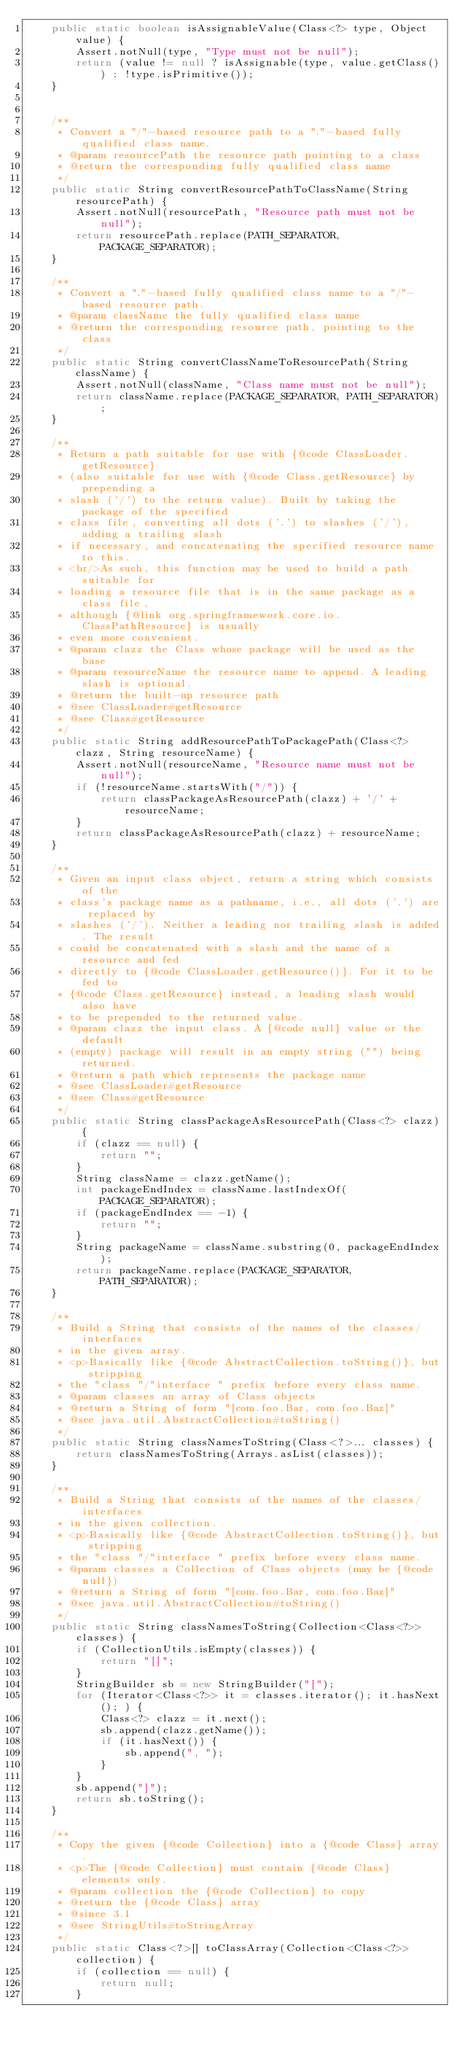Convert code to text. <code><loc_0><loc_0><loc_500><loc_500><_Java_>    public static boolean isAssignableValue(Class<?> type, Object value) {
        Assert.notNull(type, "Type must not be null");
        return (value != null ? isAssignable(type, value.getClass()) : !type.isPrimitive());
    }


    /**
     * Convert a "/"-based resource path to a "."-based fully qualified class name.
     * @param resourcePath the resource path pointing to a class
     * @return the corresponding fully qualified class name
     */
    public static String convertResourcePathToClassName(String resourcePath) {
        Assert.notNull(resourcePath, "Resource path must not be null");
        return resourcePath.replace(PATH_SEPARATOR, PACKAGE_SEPARATOR);
    }

    /**
     * Convert a "."-based fully qualified class name to a "/"-based resource path.
     * @param className the fully qualified class name
     * @return the corresponding resource path, pointing to the class
     */
    public static String convertClassNameToResourcePath(String className) {
        Assert.notNull(className, "Class name must not be null");
        return className.replace(PACKAGE_SEPARATOR, PATH_SEPARATOR);
    }

    /**
     * Return a path suitable for use with {@code ClassLoader.getResource}
     * (also suitable for use with {@code Class.getResource} by prepending a
     * slash ('/') to the return value). Built by taking the package of the specified
     * class file, converting all dots ('.') to slashes ('/'), adding a trailing slash
     * if necessary, and concatenating the specified resource name to this.
     * <br/>As such, this function may be used to build a path suitable for
     * loading a resource file that is in the same package as a class file,
     * although {@link org.springframework.core.io.ClassPathResource} is usually
     * even more convenient.
     * @param clazz the Class whose package will be used as the base
     * @param resourceName the resource name to append. A leading slash is optional.
     * @return the built-up resource path
     * @see ClassLoader#getResource
     * @see Class#getResource
     */
    public static String addResourcePathToPackagePath(Class<?> clazz, String resourceName) {
        Assert.notNull(resourceName, "Resource name must not be null");
        if (!resourceName.startsWith("/")) {
            return classPackageAsResourcePath(clazz) + '/' + resourceName;
        }
        return classPackageAsResourcePath(clazz) + resourceName;
    }

    /**
     * Given an input class object, return a string which consists of the
     * class's package name as a pathname, i.e., all dots ('.') are replaced by
     * slashes ('/'). Neither a leading nor trailing slash is added. The result
     * could be concatenated with a slash and the name of a resource and fed
     * directly to {@code ClassLoader.getResource()}. For it to be fed to
     * {@code Class.getResource} instead, a leading slash would also have
     * to be prepended to the returned value.
     * @param clazz the input class. A {@code null} value or the default
     * (empty) package will result in an empty string ("") being returned.
     * @return a path which represents the package name
     * @see ClassLoader#getResource
     * @see Class#getResource
     */
    public static String classPackageAsResourcePath(Class<?> clazz) {
        if (clazz == null) {
            return "";
        }
        String className = clazz.getName();
        int packageEndIndex = className.lastIndexOf(PACKAGE_SEPARATOR);
        if (packageEndIndex == -1) {
            return "";
        }
        String packageName = className.substring(0, packageEndIndex);
        return packageName.replace(PACKAGE_SEPARATOR, PATH_SEPARATOR);
    }

    /**
     * Build a String that consists of the names of the classes/interfaces
     * in the given array.
     * <p>Basically like {@code AbstractCollection.toString()}, but stripping
     * the "class "/"interface " prefix before every class name.
     * @param classes an array of Class objects
     * @return a String of form "[com.foo.Bar, com.foo.Baz]"
     * @see java.util.AbstractCollection#toString()
     */
    public static String classNamesToString(Class<?>... classes) {
        return classNamesToString(Arrays.asList(classes));
    }

    /**
     * Build a String that consists of the names of the classes/interfaces
     * in the given collection.
     * <p>Basically like {@code AbstractCollection.toString()}, but stripping
     * the "class "/"interface " prefix before every class name.
     * @param classes a Collection of Class objects (may be {@code null})
     * @return a String of form "[com.foo.Bar, com.foo.Baz]"
     * @see java.util.AbstractCollection#toString()
     */
    public static String classNamesToString(Collection<Class<?>> classes) {
        if (CollectionUtils.isEmpty(classes)) {
            return "[]";
        }
        StringBuilder sb = new StringBuilder("[");
        for (Iterator<Class<?>> it = classes.iterator(); it.hasNext(); ) {
            Class<?> clazz = it.next();
            sb.append(clazz.getName());
            if (it.hasNext()) {
                sb.append(", ");
            }
        }
        sb.append("]");
        return sb.toString();
    }

    /**
     * Copy the given {@code Collection} into a {@code Class} array.
     * <p>The {@code Collection} must contain {@code Class} elements only.
     * @param collection the {@code Collection} to copy
     * @return the {@code Class} array
     * @since 3.1
     * @see StringUtils#toStringArray
     */
    public static Class<?>[] toClassArray(Collection<Class<?>> collection) {
        if (collection == null) {
            return null;
        }</code> 